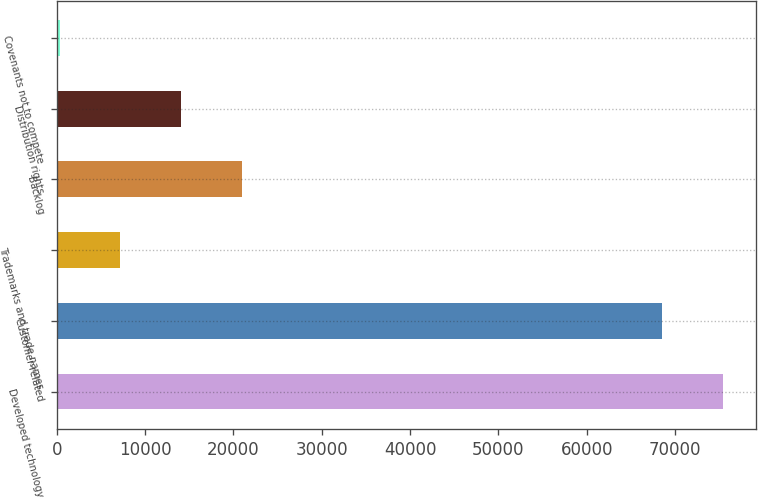<chart> <loc_0><loc_0><loc_500><loc_500><bar_chart><fcel>Developed technology<fcel>Customer-related<fcel>Trademarks and trade names<fcel>Backlog<fcel>Distribution rights<fcel>Covenants not to compete<nl><fcel>75399.4<fcel>68522<fcel>7210.4<fcel>20965.2<fcel>14087.8<fcel>333<nl></chart> 